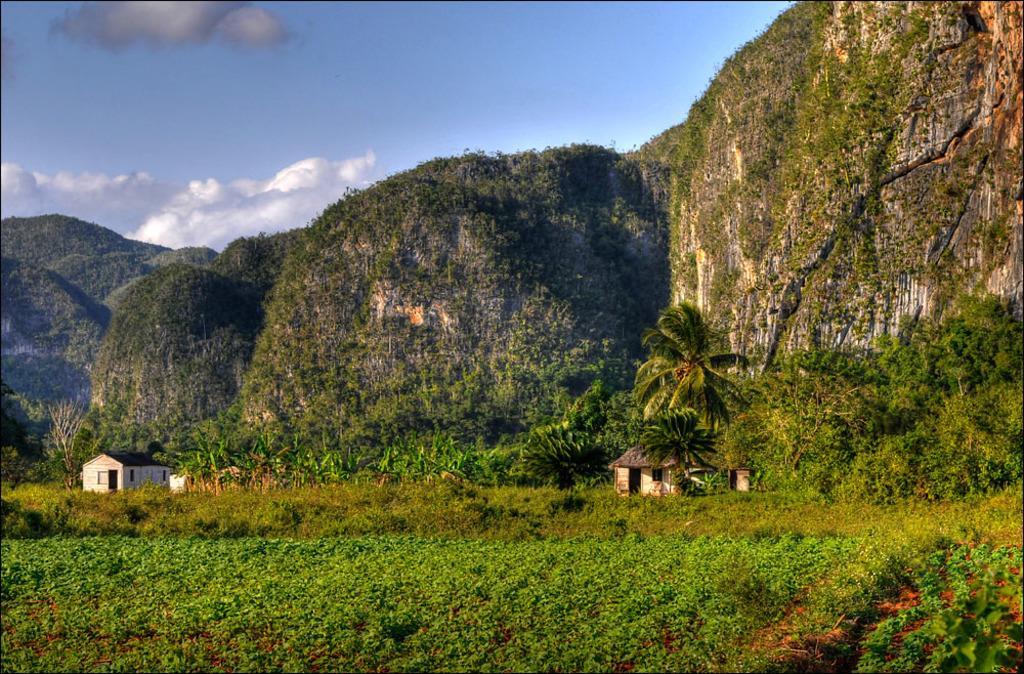In one or two sentences, can you explain what this image depicts? In this picture, there are hills covered with the grass and plants. In the center there are houses, trees, plants etc. At the bottom there are plants. 